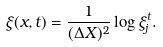<formula> <loc_0><loc_0><loc_500><loc_500>\xi ( x , t ) = \frac { 1 } { ( \Delta X ) ^ { 2 } } \log \xi _ { j } ^ { t } .</formula> 